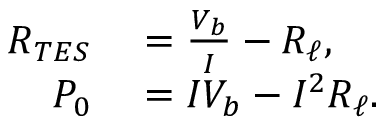<formula> <loc_0><loc_0><loc_500><loc_500>\begin{array} { r l } { R _ { T E S } } & = \frac { V _ { b } } { I } - R _ { \ell } , } \\ { P _ { 0 } } & = I V _ { b } - I ^ { 2 } R _ { \ell } . } \end{array}</formula> 